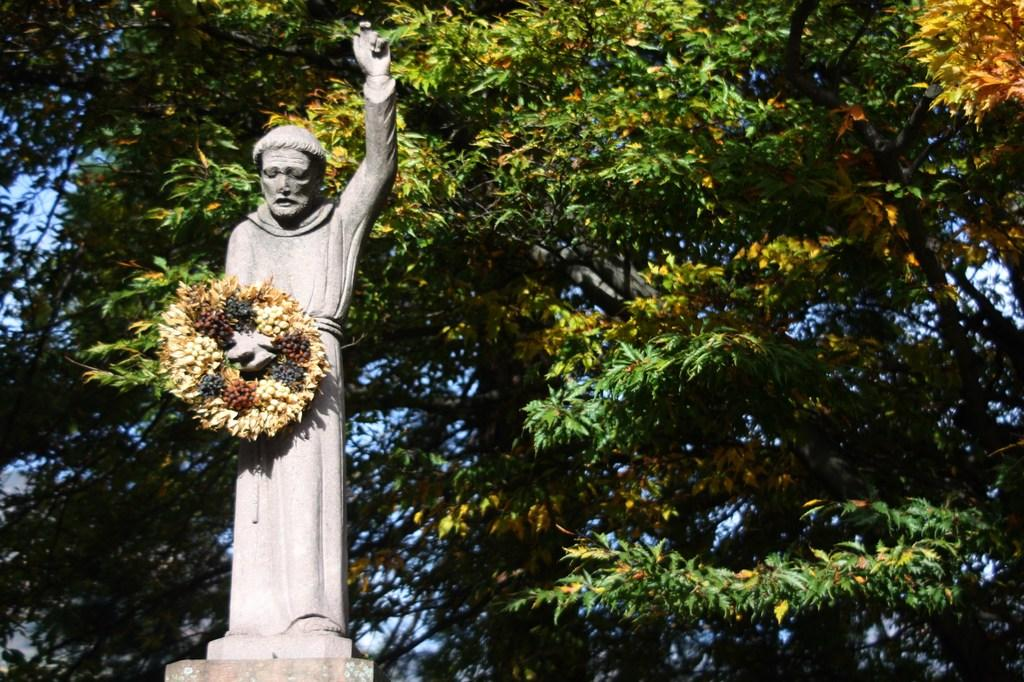What is the main subject of the image? The main subject of the image is a human statue. What is the human statue wearing or holding? The human statue has a garland. What can be seen in the background of the image? There are trees and the sky visible in the background of the image. What type of teaching method is being demonstrated by the human statue in the image? There is no teaching method being demonstrated by the human statue in the image, as it is a statue and not a person actively teaching. 